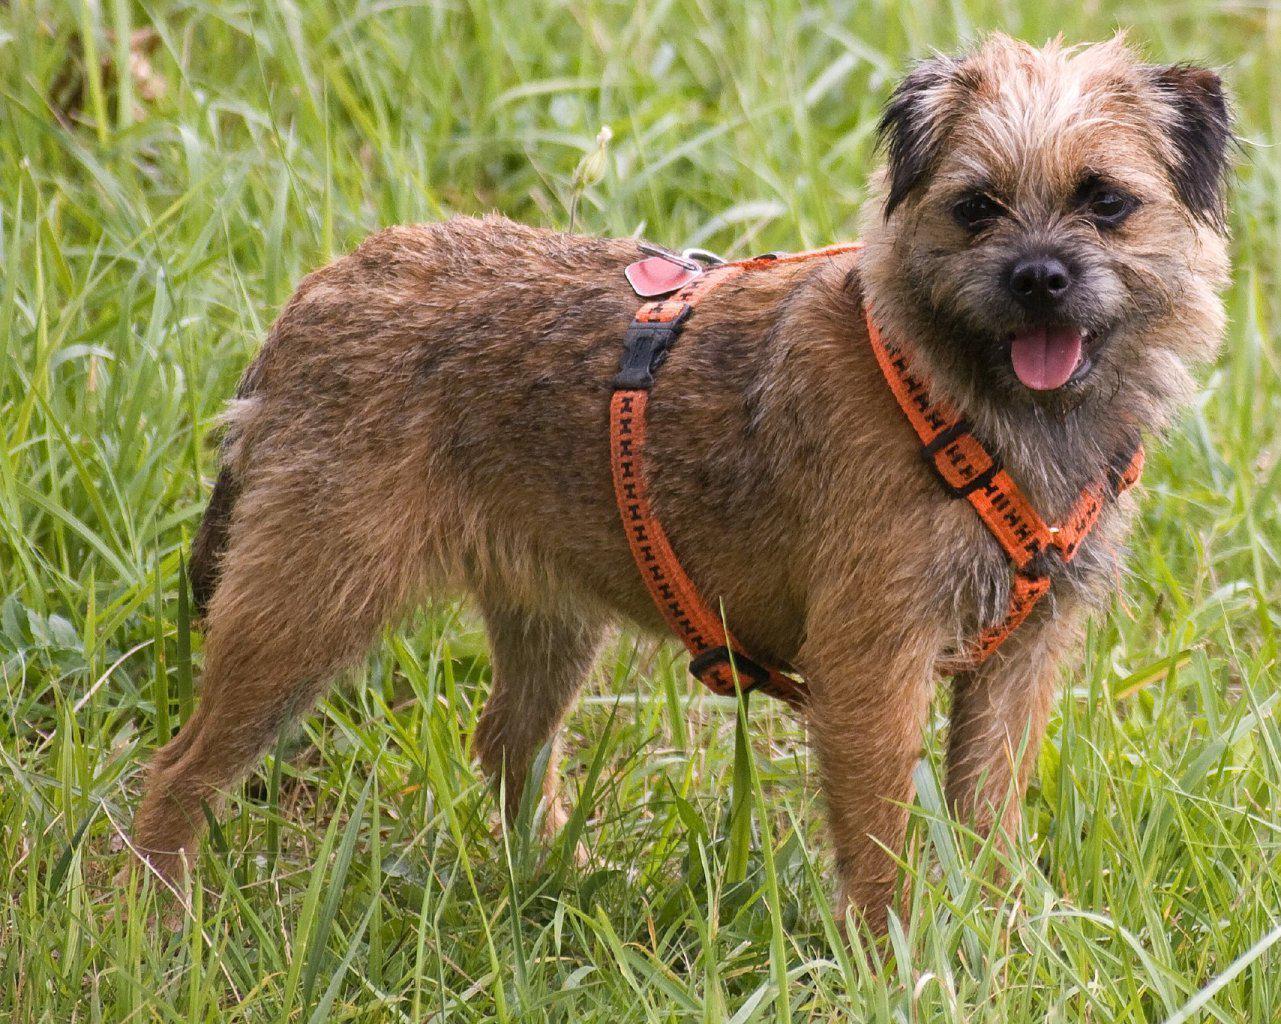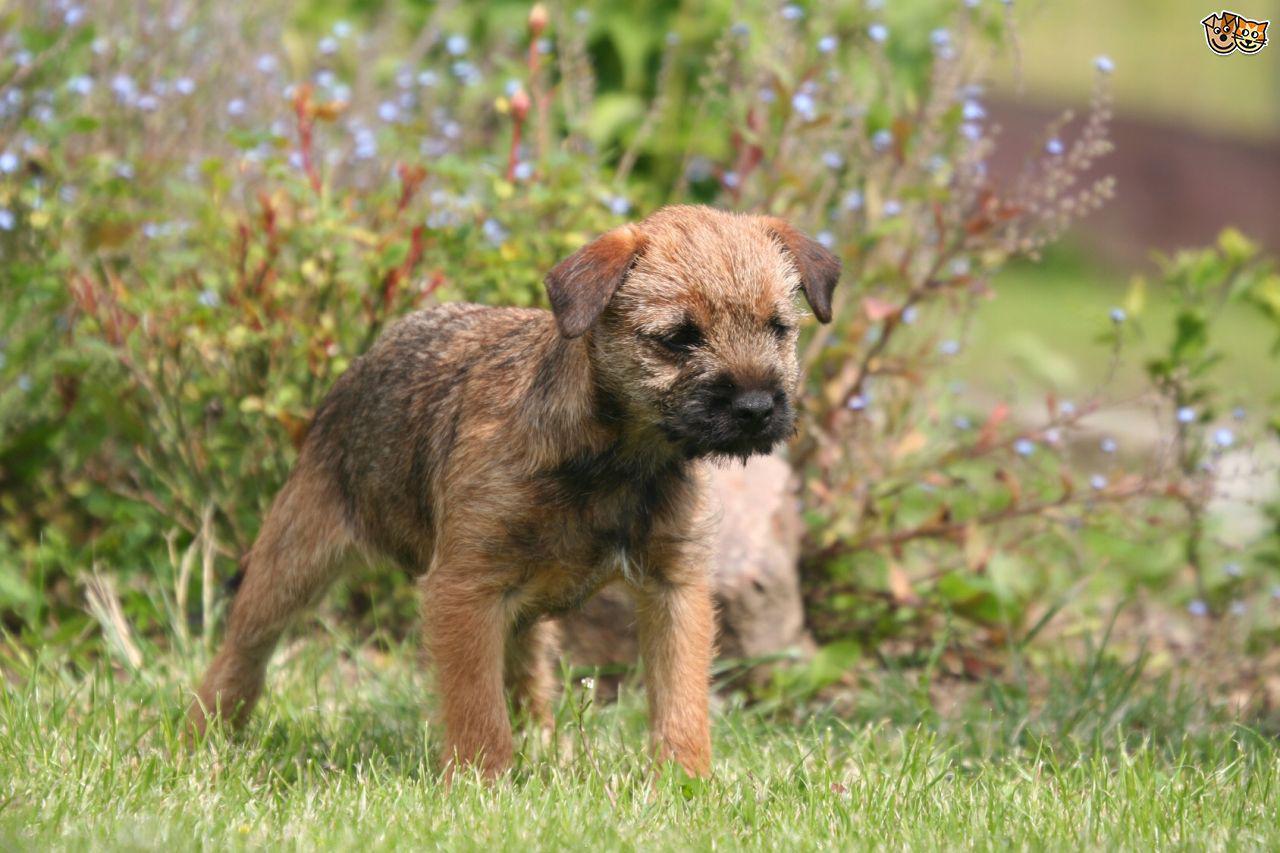The first image is the image on the left, the second image is the image on the right. For the images shown, is this caption "One of the dogs is wearing something colorful around its neck area." true? Answer yes or no. Yes. 